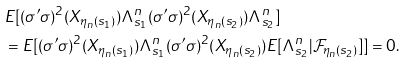Convert formula to latex. <formula><loc_0><loc_0><loc_500><loc_500>& E [ ( \sigma ^ { \prime } \sigma ) ^ { 2 } ( X _ { \eta _ { n } ( s _ { 1 } ) } ) \Lambda ^ { n } _ { s _ { 1 } } ( \sigma ^ { \prime } \sigma ) ^ { 2 } ( X _ { \eta _ { n } ( s _ { 2 } ) } ) \Lambda ^ { n } _ { s _ { 2 } } ] \\ & = E [ ( \sigma ^ { \prime } \sigma ) ^ { 2 } ( X _ { \eta _ { n } ( s _ { 1 } ) } ) \Lambda ^ { n } _ { s _ { 1 } } ( \sigma ^ { \prime } \sigma ) ^ { 2 } ( X _ { \eta _ { n } ( s _ { 2 } ) } ) E [ \Lambda ^ { n } _ { s _ { 2 } } | \mathcal { F } _ { \eta _ { n } ( s _ { 2 } ) } ] ] = 0 .</formula> 